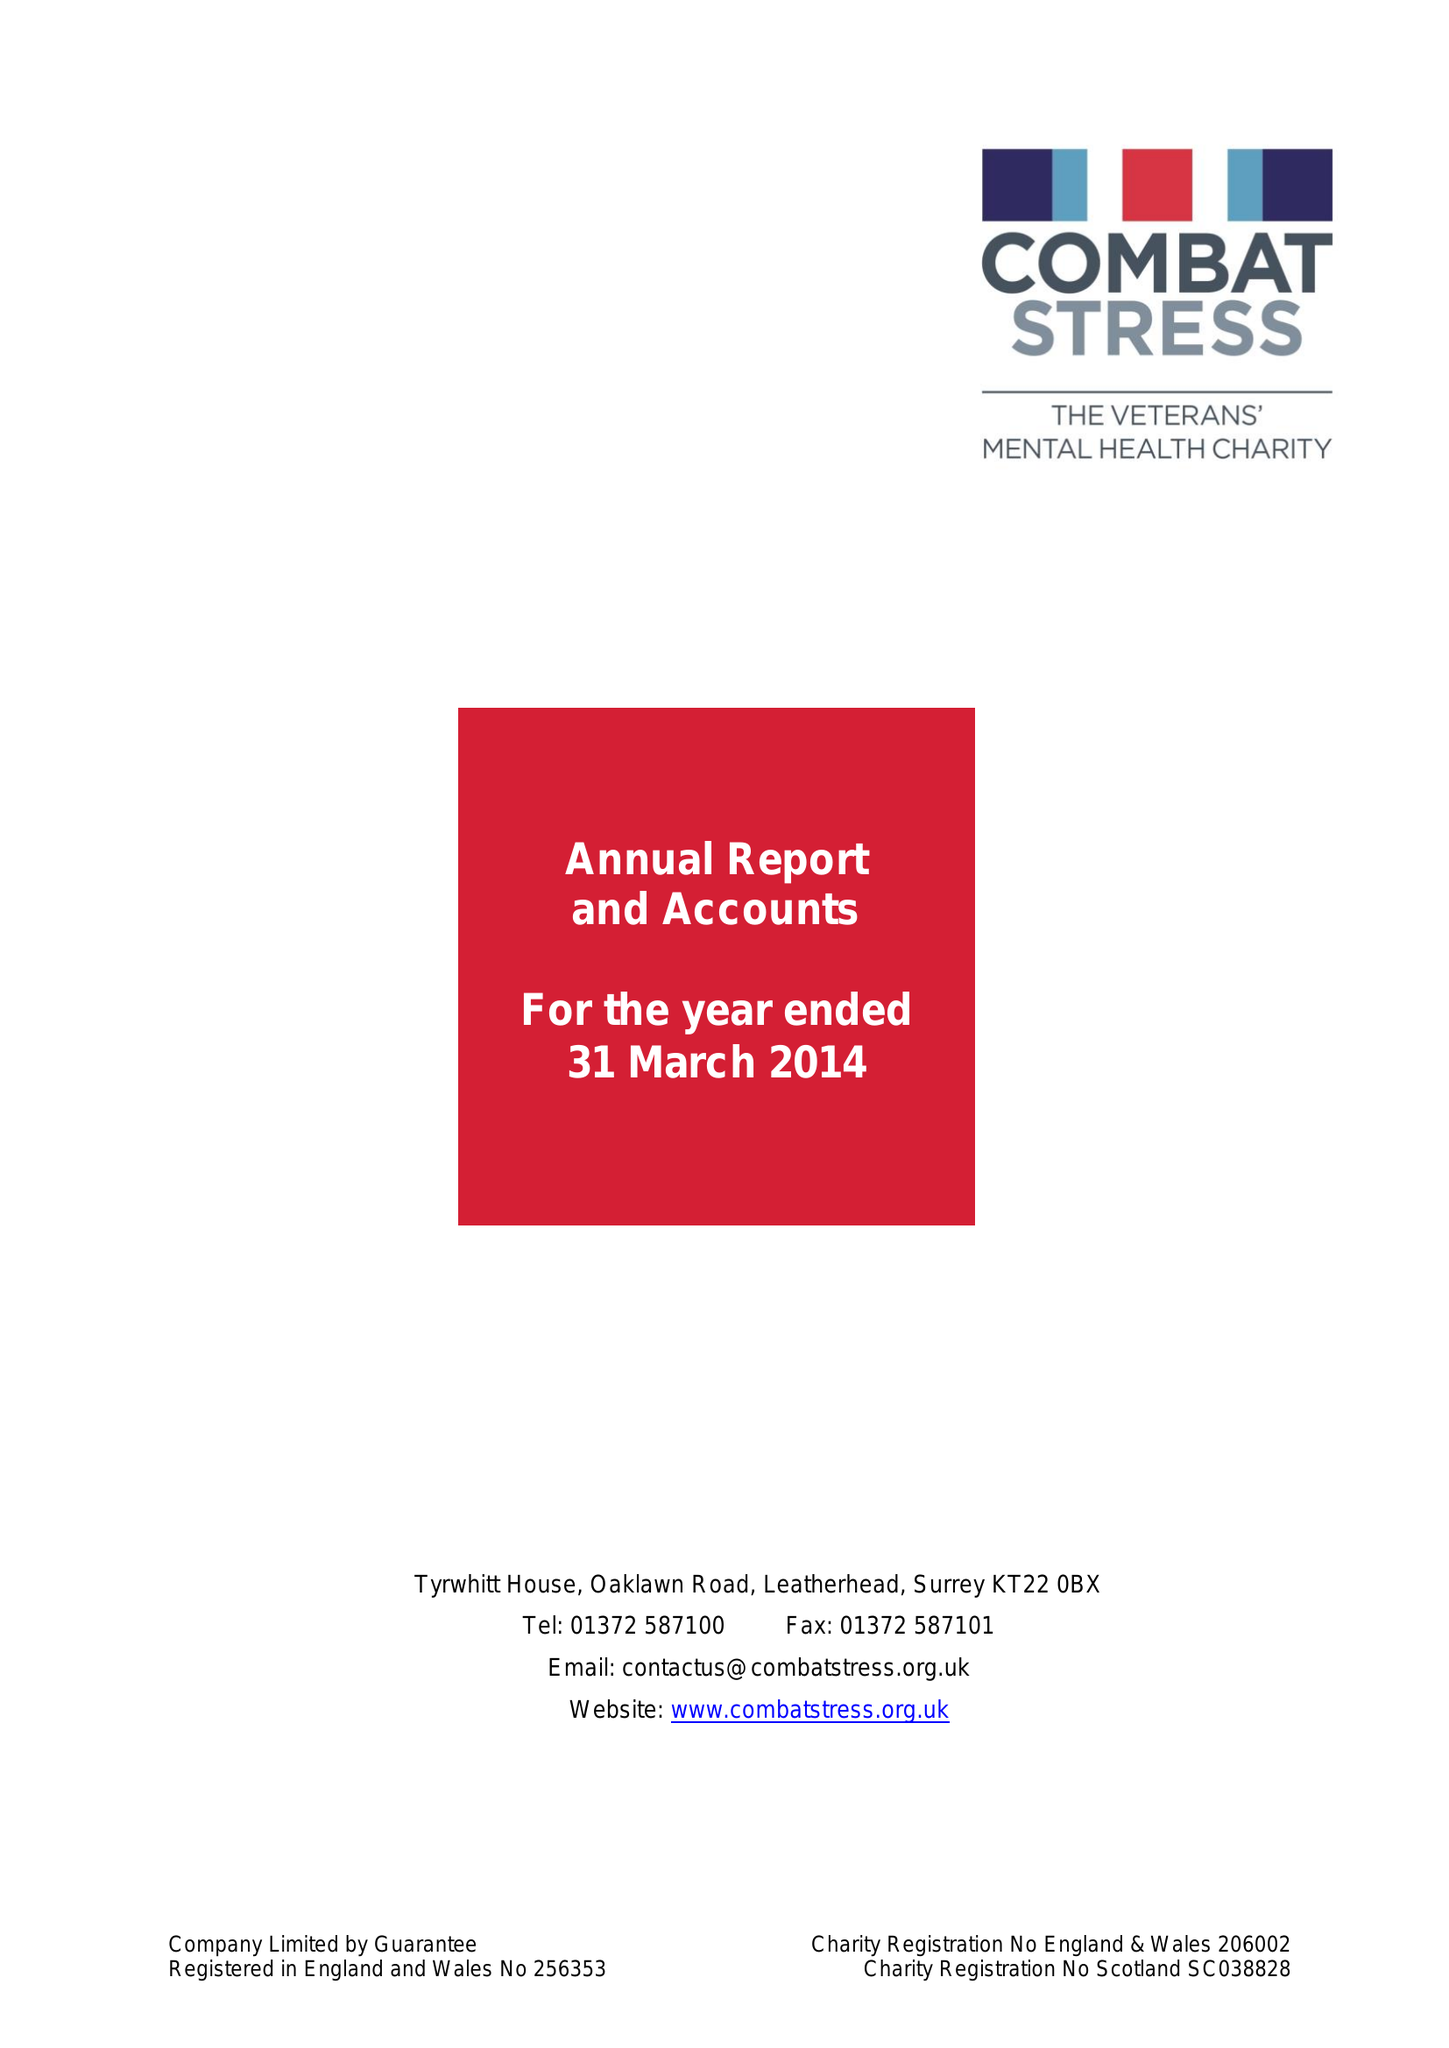What is the value for the spending_annually_in_british_pounds?
Answer the question using a single word or phrase. 16002000.00 